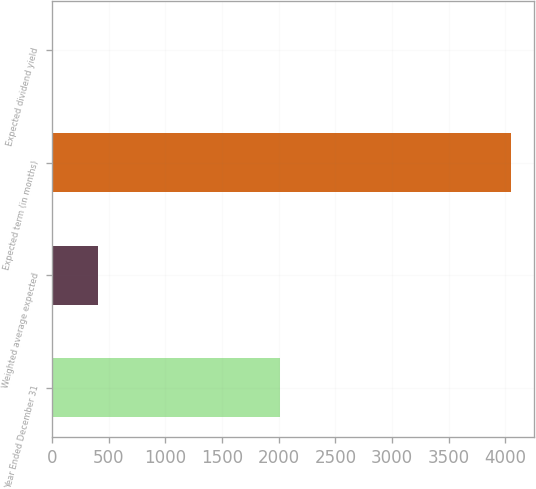<chart> <loc_0><loc_0><loc_500><loc_500><bar_chart><fcel>Year Ended December 31<fcel>Weighted average expected<fcel>Expected term (in months)<fcel>Expected dividend yield<nl><fcel>2010<fcel>406.8<fcel>4050<fcel>2<nl></chart> 